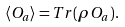<formula> <loc_0><loc_0><loc_500><loc_500>\langle O _ { a } \rangle = T r ( \rho O _ { a } ) .</formula> 